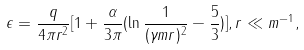Convert formula to latex. <formula><loc_0><loc_0><loc_500><loc_500>\epsilon = \frac { q } { 4 \pi r ^ { 2 } } [ 1 + \frac { \alpha } { 3 \pi } ( \ln \frac { 1 } { ( \gamma m r ) ^ { 2 } } - \frac { 5 } { 3 } ) ] , r \ll m ^ { - 1 } ,</formula> 